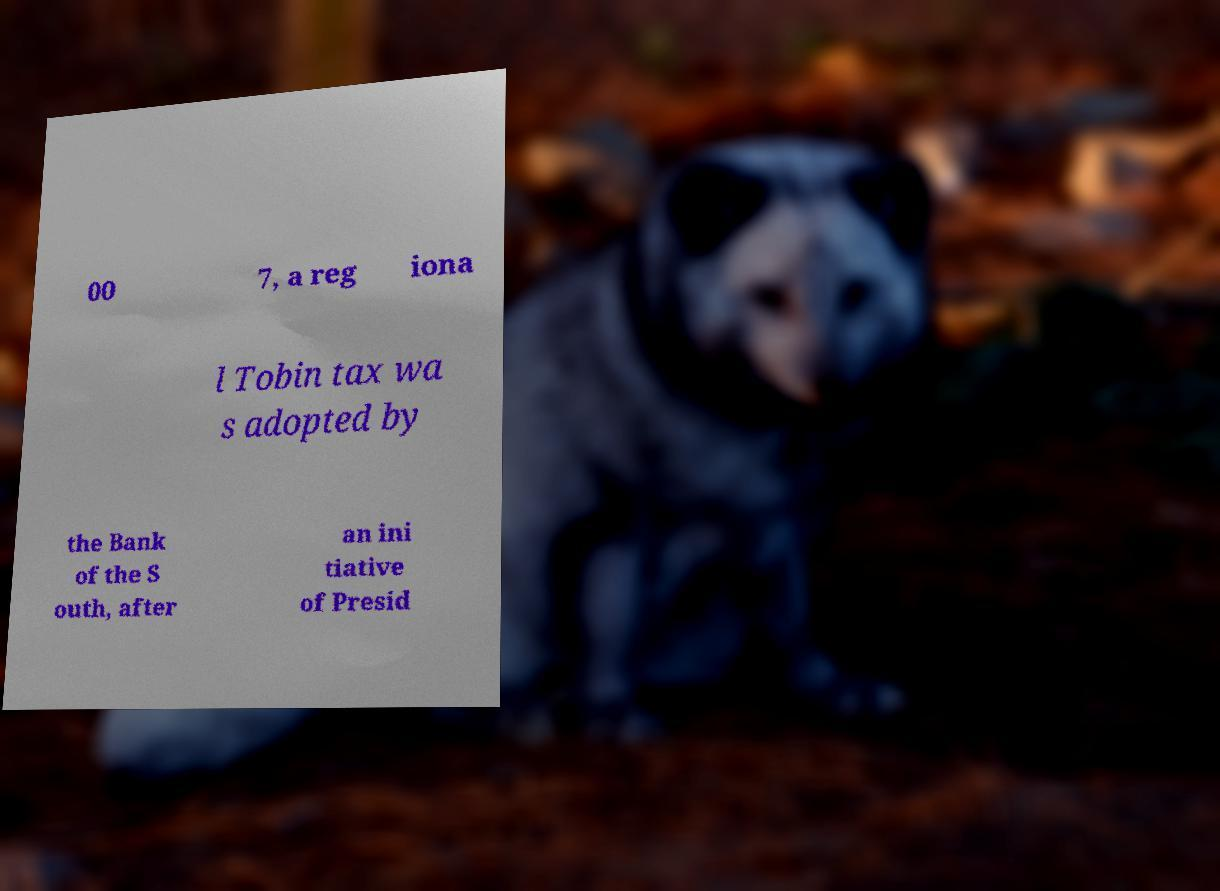Can you read and provide the text displayed in the image?This photo seems to have some interesting text. Can you extract and type it out for me? 00 7, a reg iona l Tobin tax wa s adopted by the Bank of the S outh, after an ini tiative of Presid 